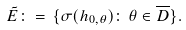Convert formula to latex. <formula><loc_0><loc_0><loc_500><loc_500>\tilde { E } \colon = \, \{ \sigma ( h _ { 0 , \theta } ) \colon \, \theta \in \overline { D } \} .</formula> 